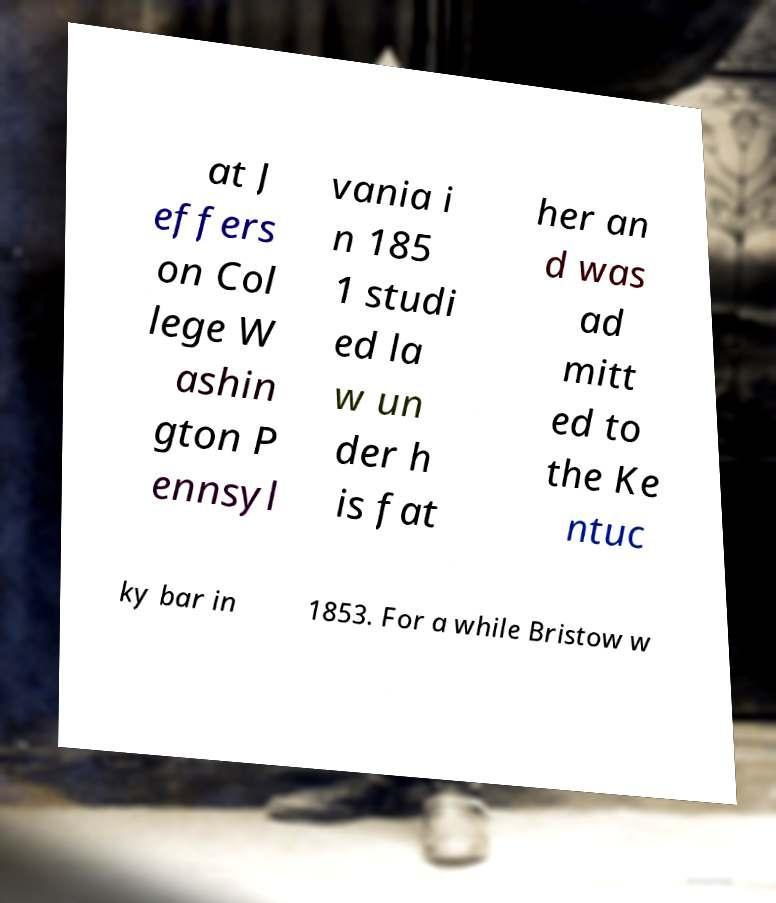Can you accurately transcribe the text from the provided image for me? at J effers on Col lege W ashin gton P ennsyl vania i n 185 1 studi ed la w un der h is fat her an d was ad mitt ed to the Ke ntuc ky bar in 1853. For a while Bristow w 